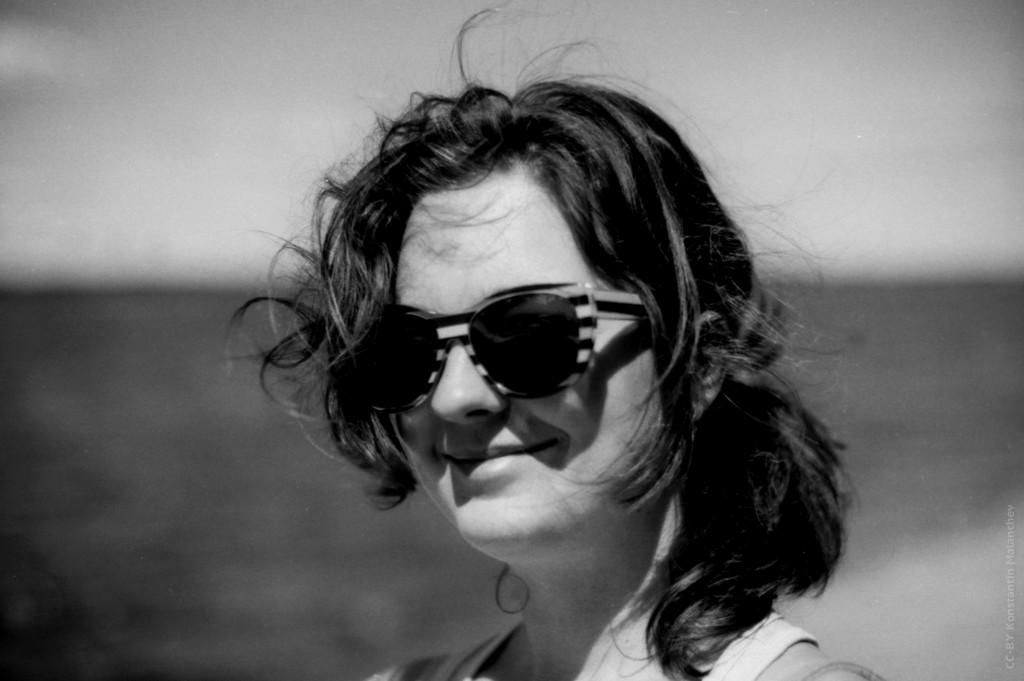Who is the main subject in the image? There is a lady in the image. What is the lady doing in the image? The lady is smiling in the image. What accessory is the lady wearing in the image? The lady is wearing glasses in the image. Why is the lady crying in the image? There is no indication in the image that the lady is crying; she is smiling instead. 